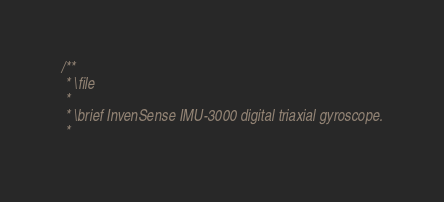Convert code to text. <code><loc_0><loc_0><loc_500><loc_500><_C_>/**
 * \file
 *
 * \brief InvenSense IMU-3000 digital triaxial gyroscope.
 *</code> 